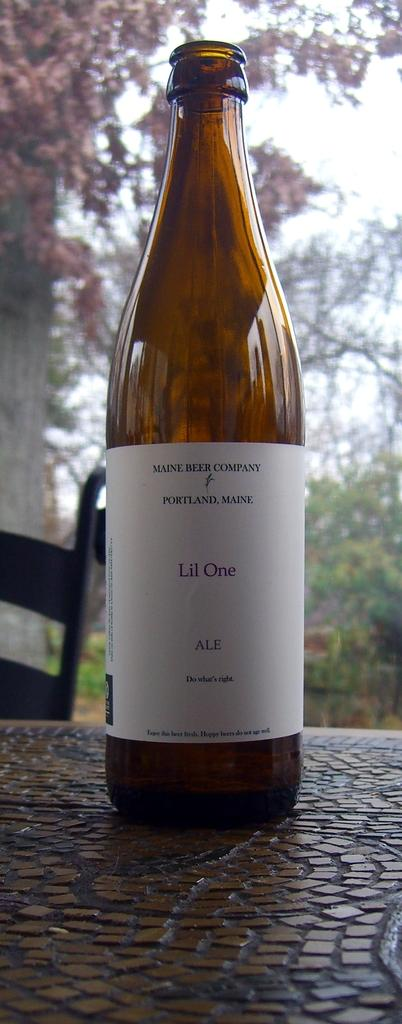What is on the table in the image? There is a wine bottle on the table. What type of vegetation can be seen in the image? There is a tree visible in the image. What type of cheese is being used to answer the questions about the image? There is no cheese present in the image or being used to answer the questions. 